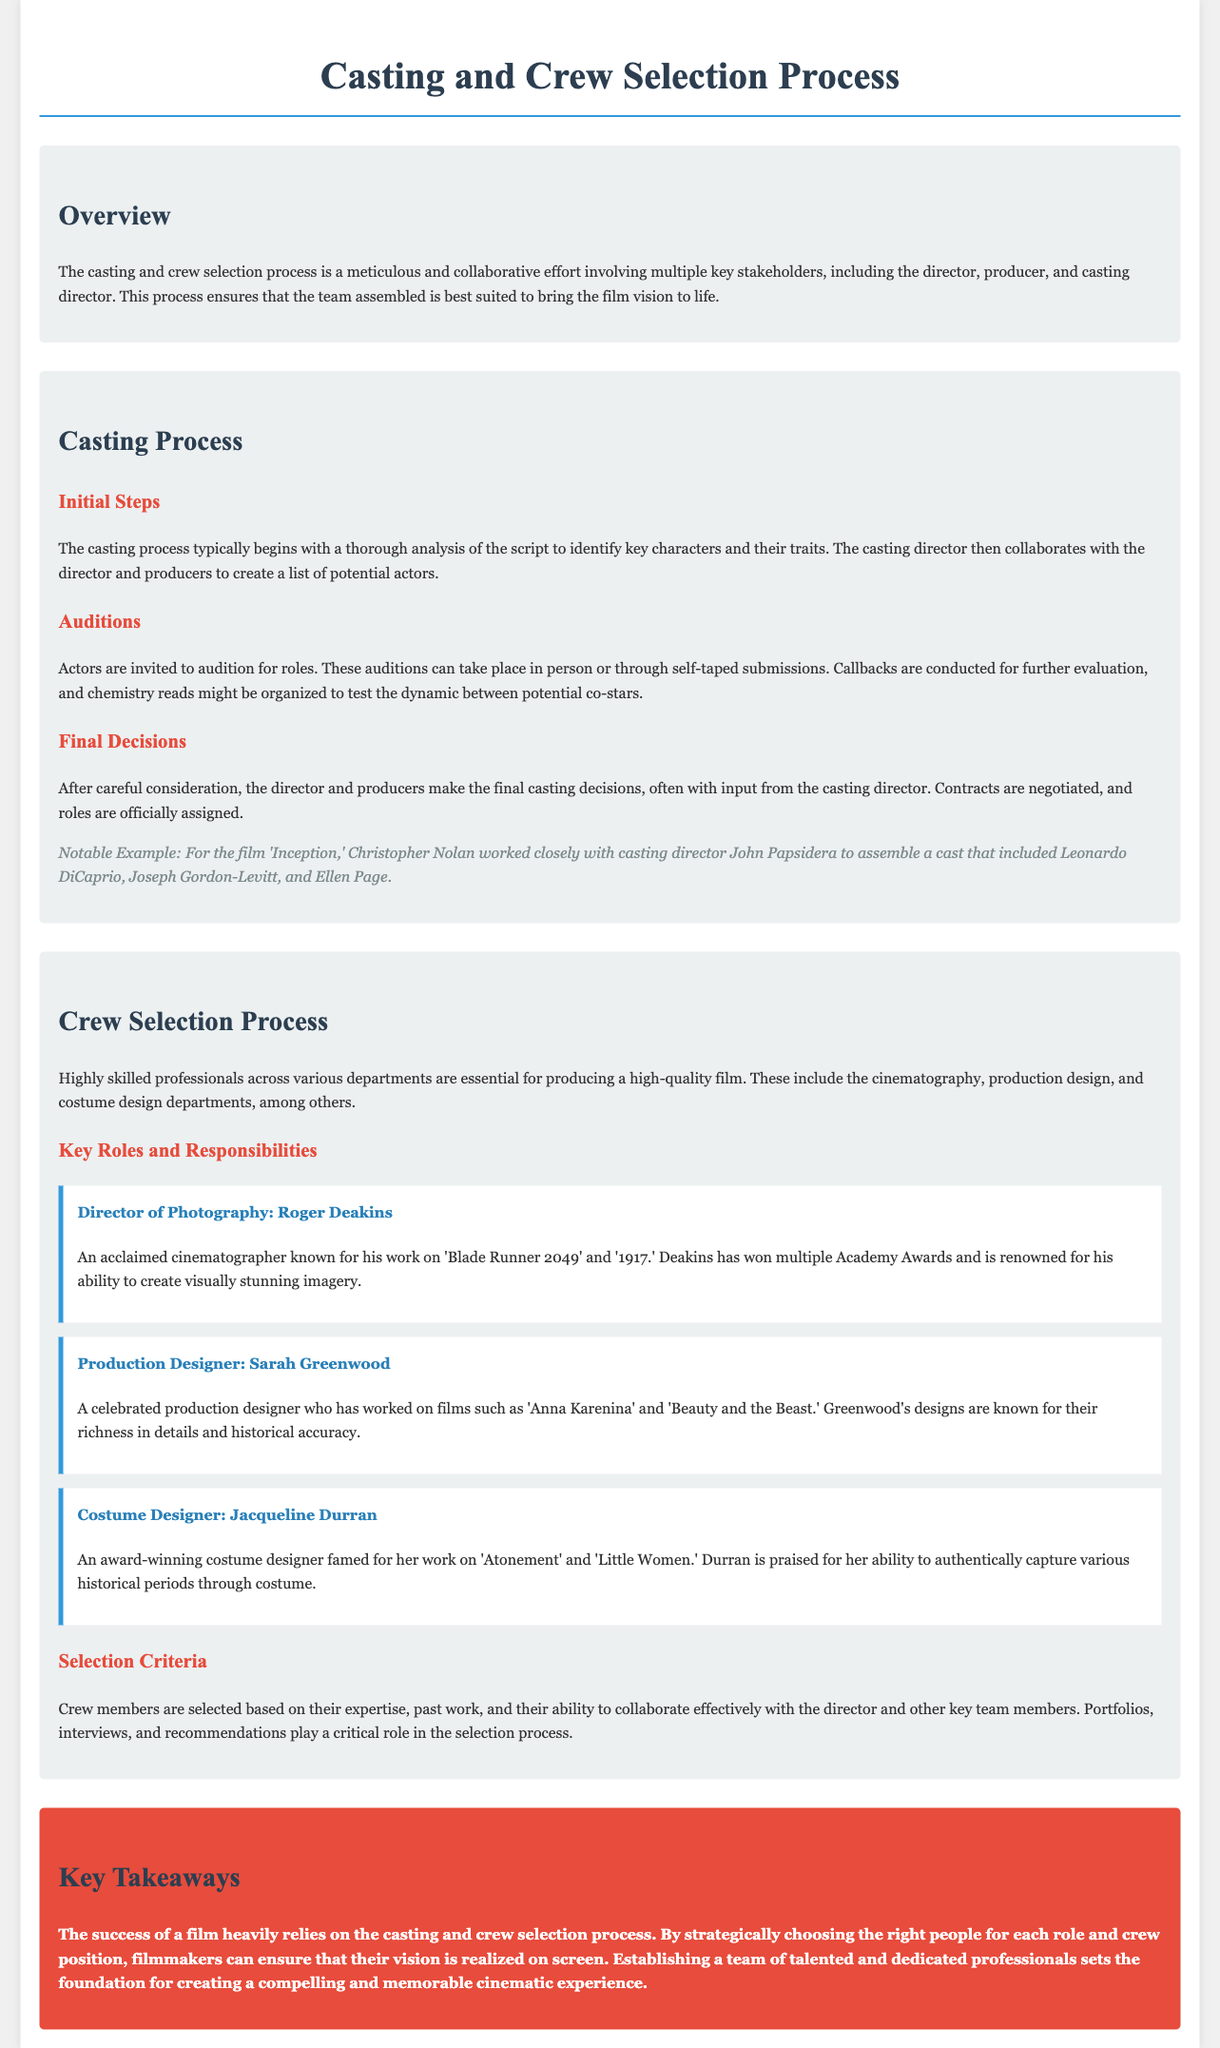What is the title of the document? The title of the document is presented in the header section of the page.
Answer: Casting and Crew Selection Process Who collaborates with the casting director? The document specifies key stakeholders involved in the casting process.
Answer: Director and producers What notable film is mentioned in the casting process example? The document gives a specific example of a film associated with the casting director.
Answer: Inception Who is the Director of Photography mentioned? The document lists key crew members and their roles.
Answer: Roger Deakins How many key roles and responsibilities are defined in the crew selection process? The document lists three key crew members with their roles and descriptions.
Answer: Three What is a critical selection criterion for crew members? The document outlines important factors for selecting crew members.
Answer: Expertise What role does Jacqueline Durran have? The document identifies specific roles of crew members and their contributions.
Answer: Costume Designer What is the background color of the key takeaways section? The document describes the style and appearance of various sections, including the key takeaways.
Answer: Red What is the purpose of the casting and crew selection process? The document explains the overall goal of this selection process in film production.
Answer: To realize the film vision on screen 